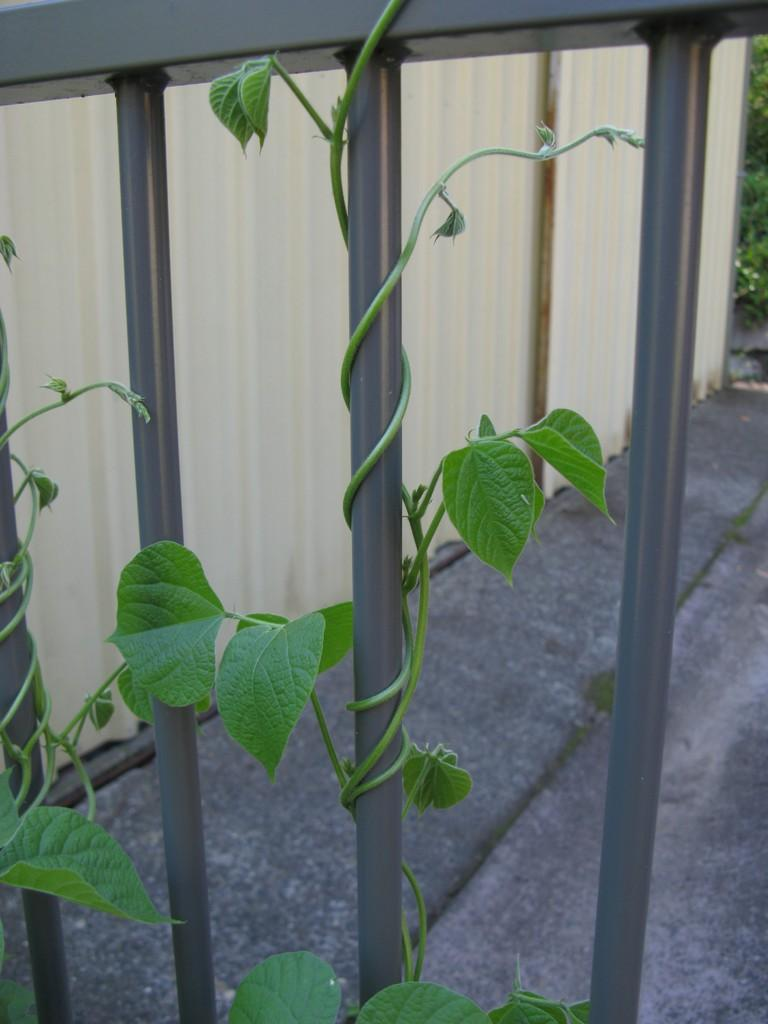What is growing on the railing in the image? There is a creeper on the railing in the image. What else can be seen in the image besides the creeper? There are plants visible in the image. What type of structure is present in the image? There is a wall in the image. What type of cake is being served on the wall in the image? There is no cake present in the image; it features a creeper on the railing and plants near a wall. How does the creeper express its feelings of hate towards the wall in the image? The creeper does not express any feelings in the image; it is a plant growing on the railing. 